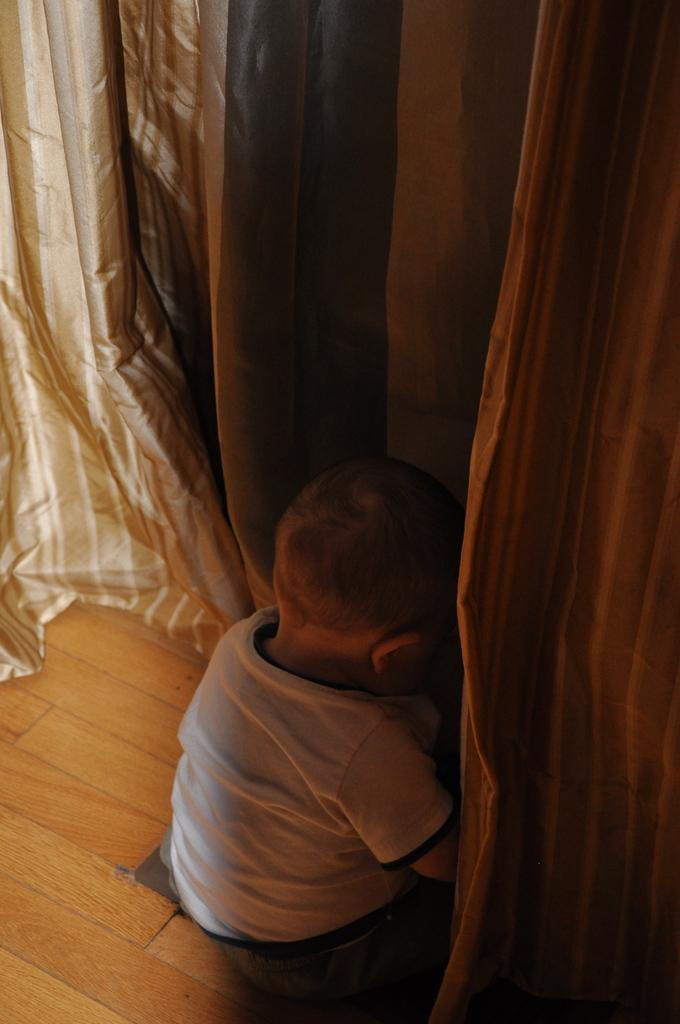What is the main subject of the image? There is a small baby in the center of the image. What can be seen at the top side of the image? There are curtains at the top side of the image. What type of toys does the committee use to make decisions in the image? There is no committee or toys present in the image; it features a small baby and curtains. 